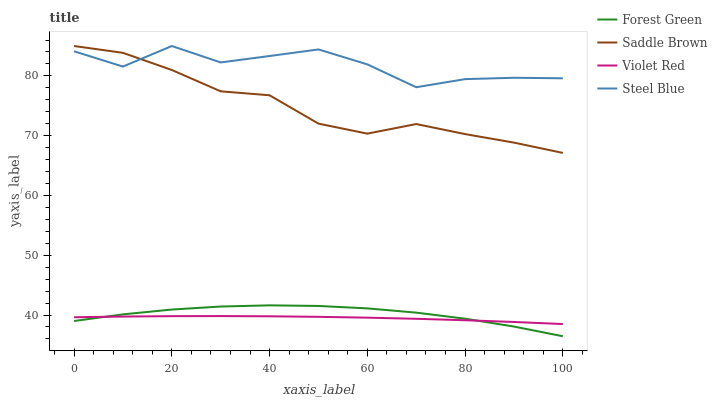Does Violet Red have the minimum area under the curve?
Answer yes or no. Yes. Does Steel Blue have the maximum area under the curve?
Answer yes or no. Yes. Does Forest Green have the minimum area under the curve?
Answer yes or no. No. Does Forest Green have the maximum area under the curve?
Answer yes or no. No. Is Violet Red the smoothest?
Answer yes or no. Yes. Is Steel Blue the roughest?
Answer yes or no. Yes. Is Forest Green the smoothest?
Answer yes or no. No. Is Forest Green the roughest?
Answer yes or no. No. Does Forest Green have the lowest value?
Answer yes or no. Yes. Does Saddle Brown have the lowest value?
Answer yes or no. No. Does Steel Blue have the highest value?
Answer yes or no. Yes. Does Forest Green have the highest value?
Answer yes or no. No. Is Violet Red less than Saddle Brown?
Answer yes or no. Yes. Is Steel Blue greater than Forest Green?
Answer yes or no. Yes. Does Steel Blue intersect Saddle Brown?
Answer yes or no. Yes. Is Steel Blue less than Saddle Brown?
Answer yes or no. No. Is Steel Blue greater than Saddle Brown?
Answer yes or no. No. Does Violet Red intersect Saddle Brown?
Answer yes or no. No. 